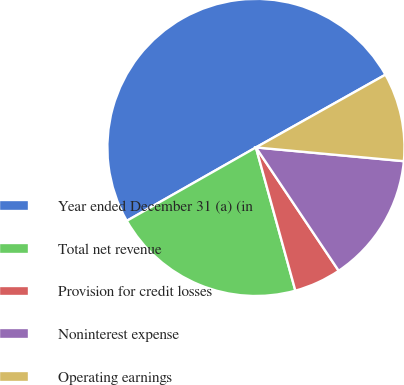<chart> <loc_0><loc_0><loc_500><loc_500><pie_chart><fcel>Year ended December 31 (a) (in<fcel>Total net revenue<fcel>Provision for credit losses<fcel>Noninterest expense<fcel>Operating earnings<nl><fcel>50.08%<fcel>21.05%<fcel>5.13%<fcel>14.12%<fcel>9.62%<nl></chart> 